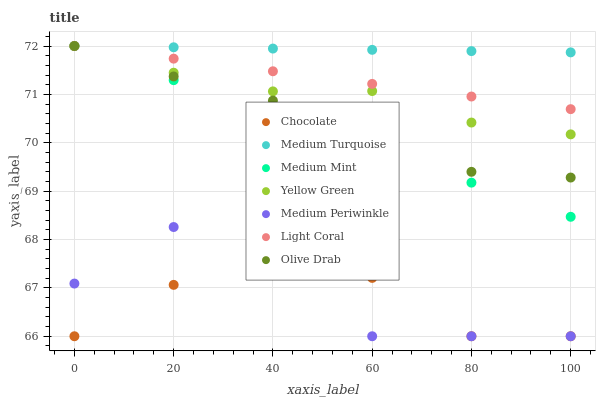Does Chocolate have the minimum area under the curve?
Answer yes or no. Yes. Does Medium Turquoise have the maximum area under the curve?
Answer yes or no. Yes. Does Yellow Green have the minimum area under the curve?
Answer yes or no. No. Does Yellow Green have the maximum area under the curve?
Answer yes or no. No. Is Medium Mint the smoothest?
Answer yes or no. Yes. Is Medium Periwinkle the roughest?
Answer yes or no. Yes. Is Yellow Green the smoothest?
Answer yes or no. No. Is Yellow Green the roughest?
Answer yes or no. No. Does Medium Periwinkle have the lowest value?
Answer yes or no. Yes. Does Yellow Green have the lowest value?
Answer yes or no. No. Does Olive Drab have the highest value?
Answer yes or no. Yes. Does Medium Periwinkle have the highest value?
Answer yes or no. No. Is Medium Periwinkle less than Olive Drab?
Answer yes or no. Yes. Is Medium Turquoise greater than Chocolate?
Answer yes or no. Yes. Does Light Coral intersect Olive Drab?
Answer yes or no. Yes. Is Light Coral less than Olive Drab?
Answer yes or no. No. Is Light Coral greater than Olive Drab?
Answer yes or no. No. Does Medium Periwinkle intersect Olive Drab?
Answer yes or no. No. 